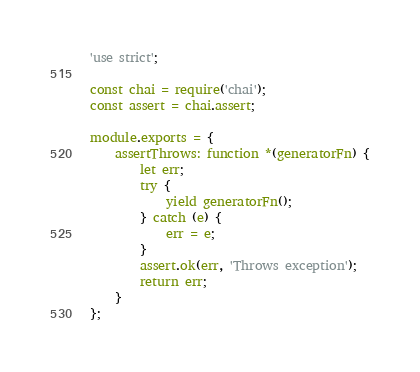<code> <loc_0><loc_0><loc_500><loc_500><_JavaScript_>'use strict';

const chai = require('chai');
const assert = chai.assert;

module.exports = {
    assertThrows: function *(generatorFn) {
        let err;
        try {
            yield generatorFn();
        } catch (e) {
            err = e;
        }
        assert.ok(err, 'Throws exception');
        return err;
    }
};</code> 